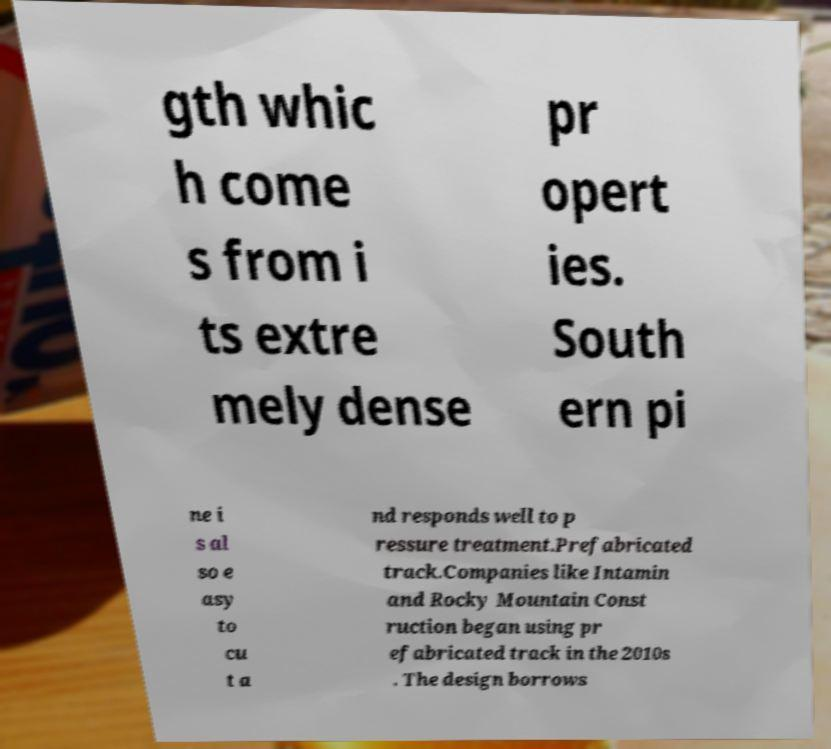For documentation purposes, I need the text within this image transcribed. Could you provide that? gth whic h come s from i ts extre mely dense pr opert ies. South ern pi ne i s al so e asy to cu t a nd responds well to p ressure treatment.Prefabricated track.Companies like Intamin and Rocky Mountain Const ruction began using pr efabricated track in the 2010s . The design borrows 